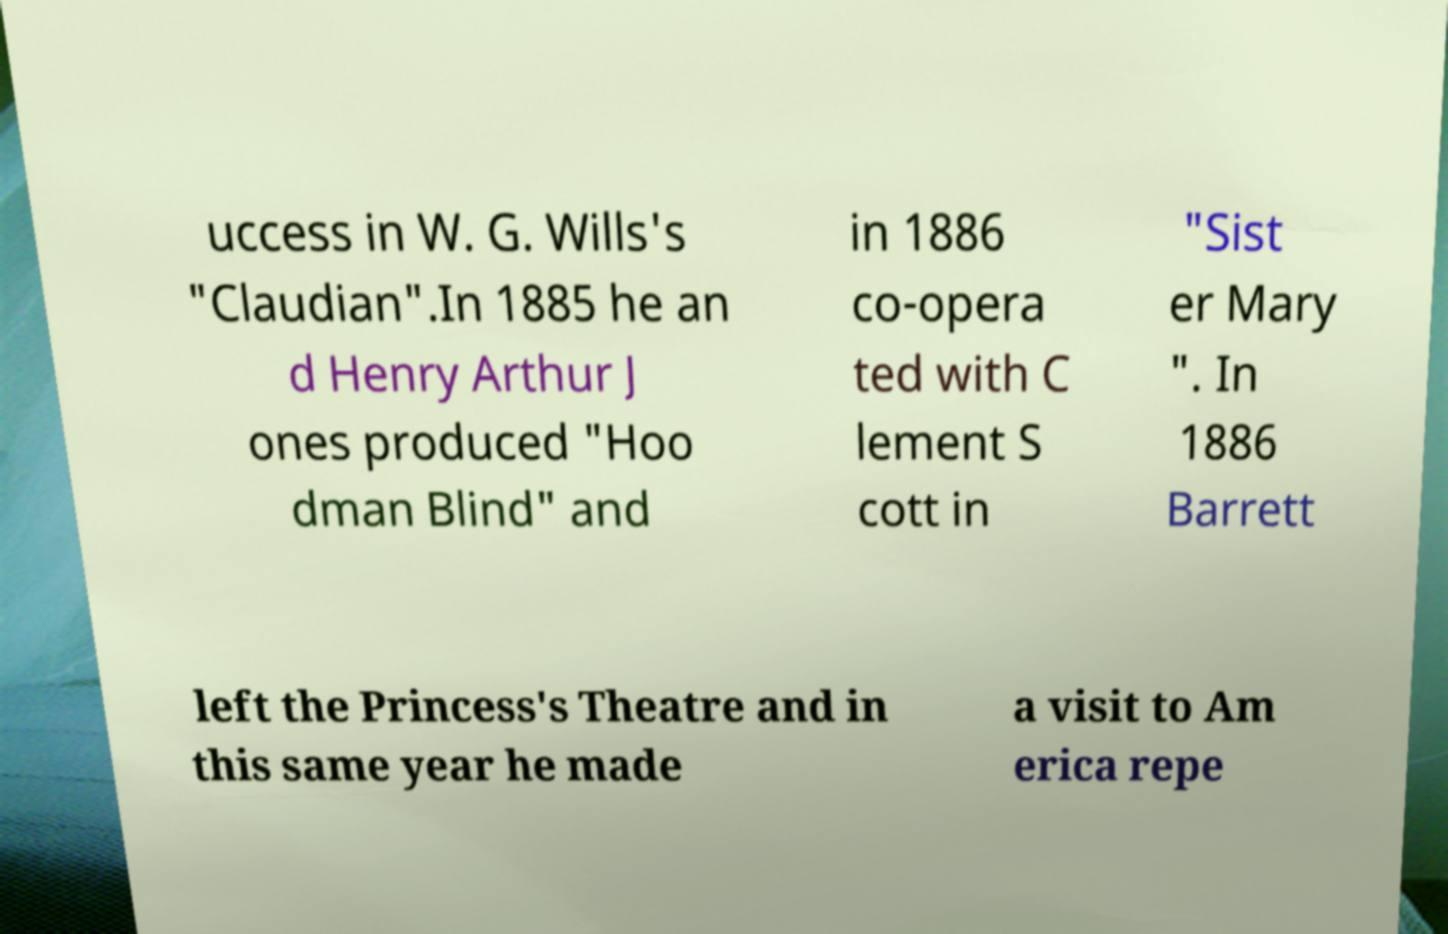I need the written content from this picture converted into text. Can you do that? uccess in W. G. Wills's "Claudian".In 1885 he an d Henry Arthur J ones produced "Hoo dman Blind" and in 1886 co-opera ted with C lement S cott in "Sist er Mary ". In 1886 Barrett left the Princess's Theatre and in this same year he made a visit to Am erica repe 